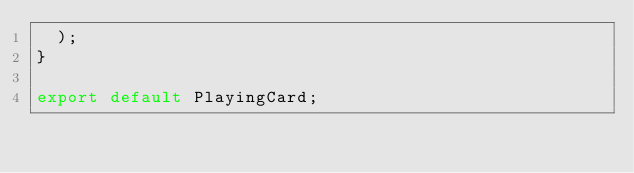Convert code to text. <code><loc_0><loc_0><loc_500><loc_500><_JavaScript_>  );
}

export default PlayingCard;
</code> 